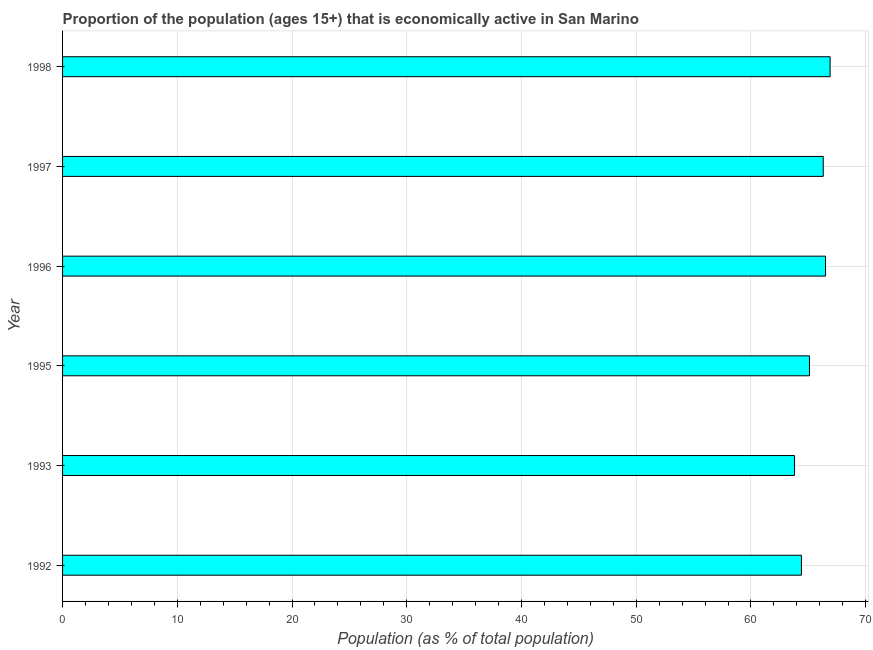What is the title of the graph?
Provide a succinct answer. Proportion of the population (ages 15+) that is economically active in San Marino. What is the label or title of the X-axis?
Give a very brief answer. Population (as % of total population). What is the percentage of economically active population in 1997?
Your answer should be very brief. 66.3. Across all years, what is the maximum percentage of economically active population?
Provide a succinct answer. 66.9. Across all years, what is the minimum percentage of economically active population?
Ensure brevity in your answer.  63.8. In which year was the percentage of economically active population minimum?
Your answer should be compact. 1993. What is the sum of the percentage of economically active population?
Offer a terse response. 393. What is the difference between the percentage of economically active population in 1995 and 1996?
Your answer should be compact. -1.4. What is the average percentage of economically active population per year?
Make the answer very short. 65.5. What is the median percentage of economically active population?
Offer a very short reply. 65.7. Do a majority of the years between 1995 and 1997 (inclusive) have percentage of economically active population greater than 54 %?
Make the answer very short. Yes. What is the ratio of the percentage of economically active population in 1996 to that in 1997?
Give a very brief answer. 1. Is the difference between the percentage of economically active population in 1993 and 1997 greater than the difference between any two years?
Ensure brevity in your answer.  No. What is the difference between the highest and the second highest percentage of economically active population?
Offer a very short reply. 0.4. In how many years, is the percentage of economically active population greater than the average percentage of economically active population taken over all years?
Offer a terse response. 3. How many years are there in the graph?
Provide a short and direct response. 6. What is the difference between two consecutive major ticks on the X-axis?
Ensure brevity in your answer.  10. Are the values on the major ticks of X-axis written in scientific E-notation?
Provide a succinct answer. No. What is the Population (as % of total population) in 1992?
Offer a very short reply. 64.4. What is the Population (as % of total population) in 1993?
Ensure brevity in your answer.  63.8. What is the Population (as % of total population) in 1995?
Keep it short and to the point. 65.1. What is the Population (as % of total population) in 1996?
Your answer should be compact. 66.5. What is the Population (as % of total population) of 1997?
Give a very brief answer. 66.3. What is the Population (as % of total population) in 1998?
Give a very brief answer. 66.9. What is the difference between the Population (as % of total population) in 1992 and 1995?
Give a very brief answer. -0.7. What is the difference between the Population (as % of total population) in 1992 and 1996?
Your answer should be compact. -2.1. What is the difference between the Population (as % of total population) in 1993 and 1995?
Provide a short and direct response. -1.3. What is the difference between the Population (as % of total population) in 1993 and 1997?
Keep it short and to the point. -2.5. What is the difference between the Population (as % of total population) in 1993 and 1998?
Give a very brief answer. -3.1. What is the difference between the Population (as % of total population) in 1995 and 1996?
Your response must be concise. -1.4. What is the difference between the Population (as % of total population) in 1995 and 1997?
Keep it short and to the point. -1.2. What is the difference between the Population (as % of total population) in 1995 and 1998?
Provide a short and direct response. -1.8. What is the difference between the Population (as % of total population) in 1996 and 1997?
Provide a short and direct response. 0.2. What is the difference between the Population (as % of total population) in 1997 and 1998?
Your answer should be very brief. -0.6. What is the ratio of the Population (as % of total population) in 1992 to that in 1996?
Your response must be concise. 0.97. What is the ratio of the Population (as % of total population) in 1993 to that in 1995?
Provide a succinct answer. 0.98. What is the ratio of the Population (as % of total population) in 1993 to that in 1996?
Your answer should be very brief. 0.96. What is the ratio of the Population (as % of total population) in 1993 to that in 1998?
Give a very brief answer. 0.95. What is the ratio of the Population (as % of total population) in 1995 to that in 1998?
Your answer should be very brief. 0.97. What is the ratio of the Population (as % of total population) in 1996 to that in 1998?
Offer a terse response. 0.99. 